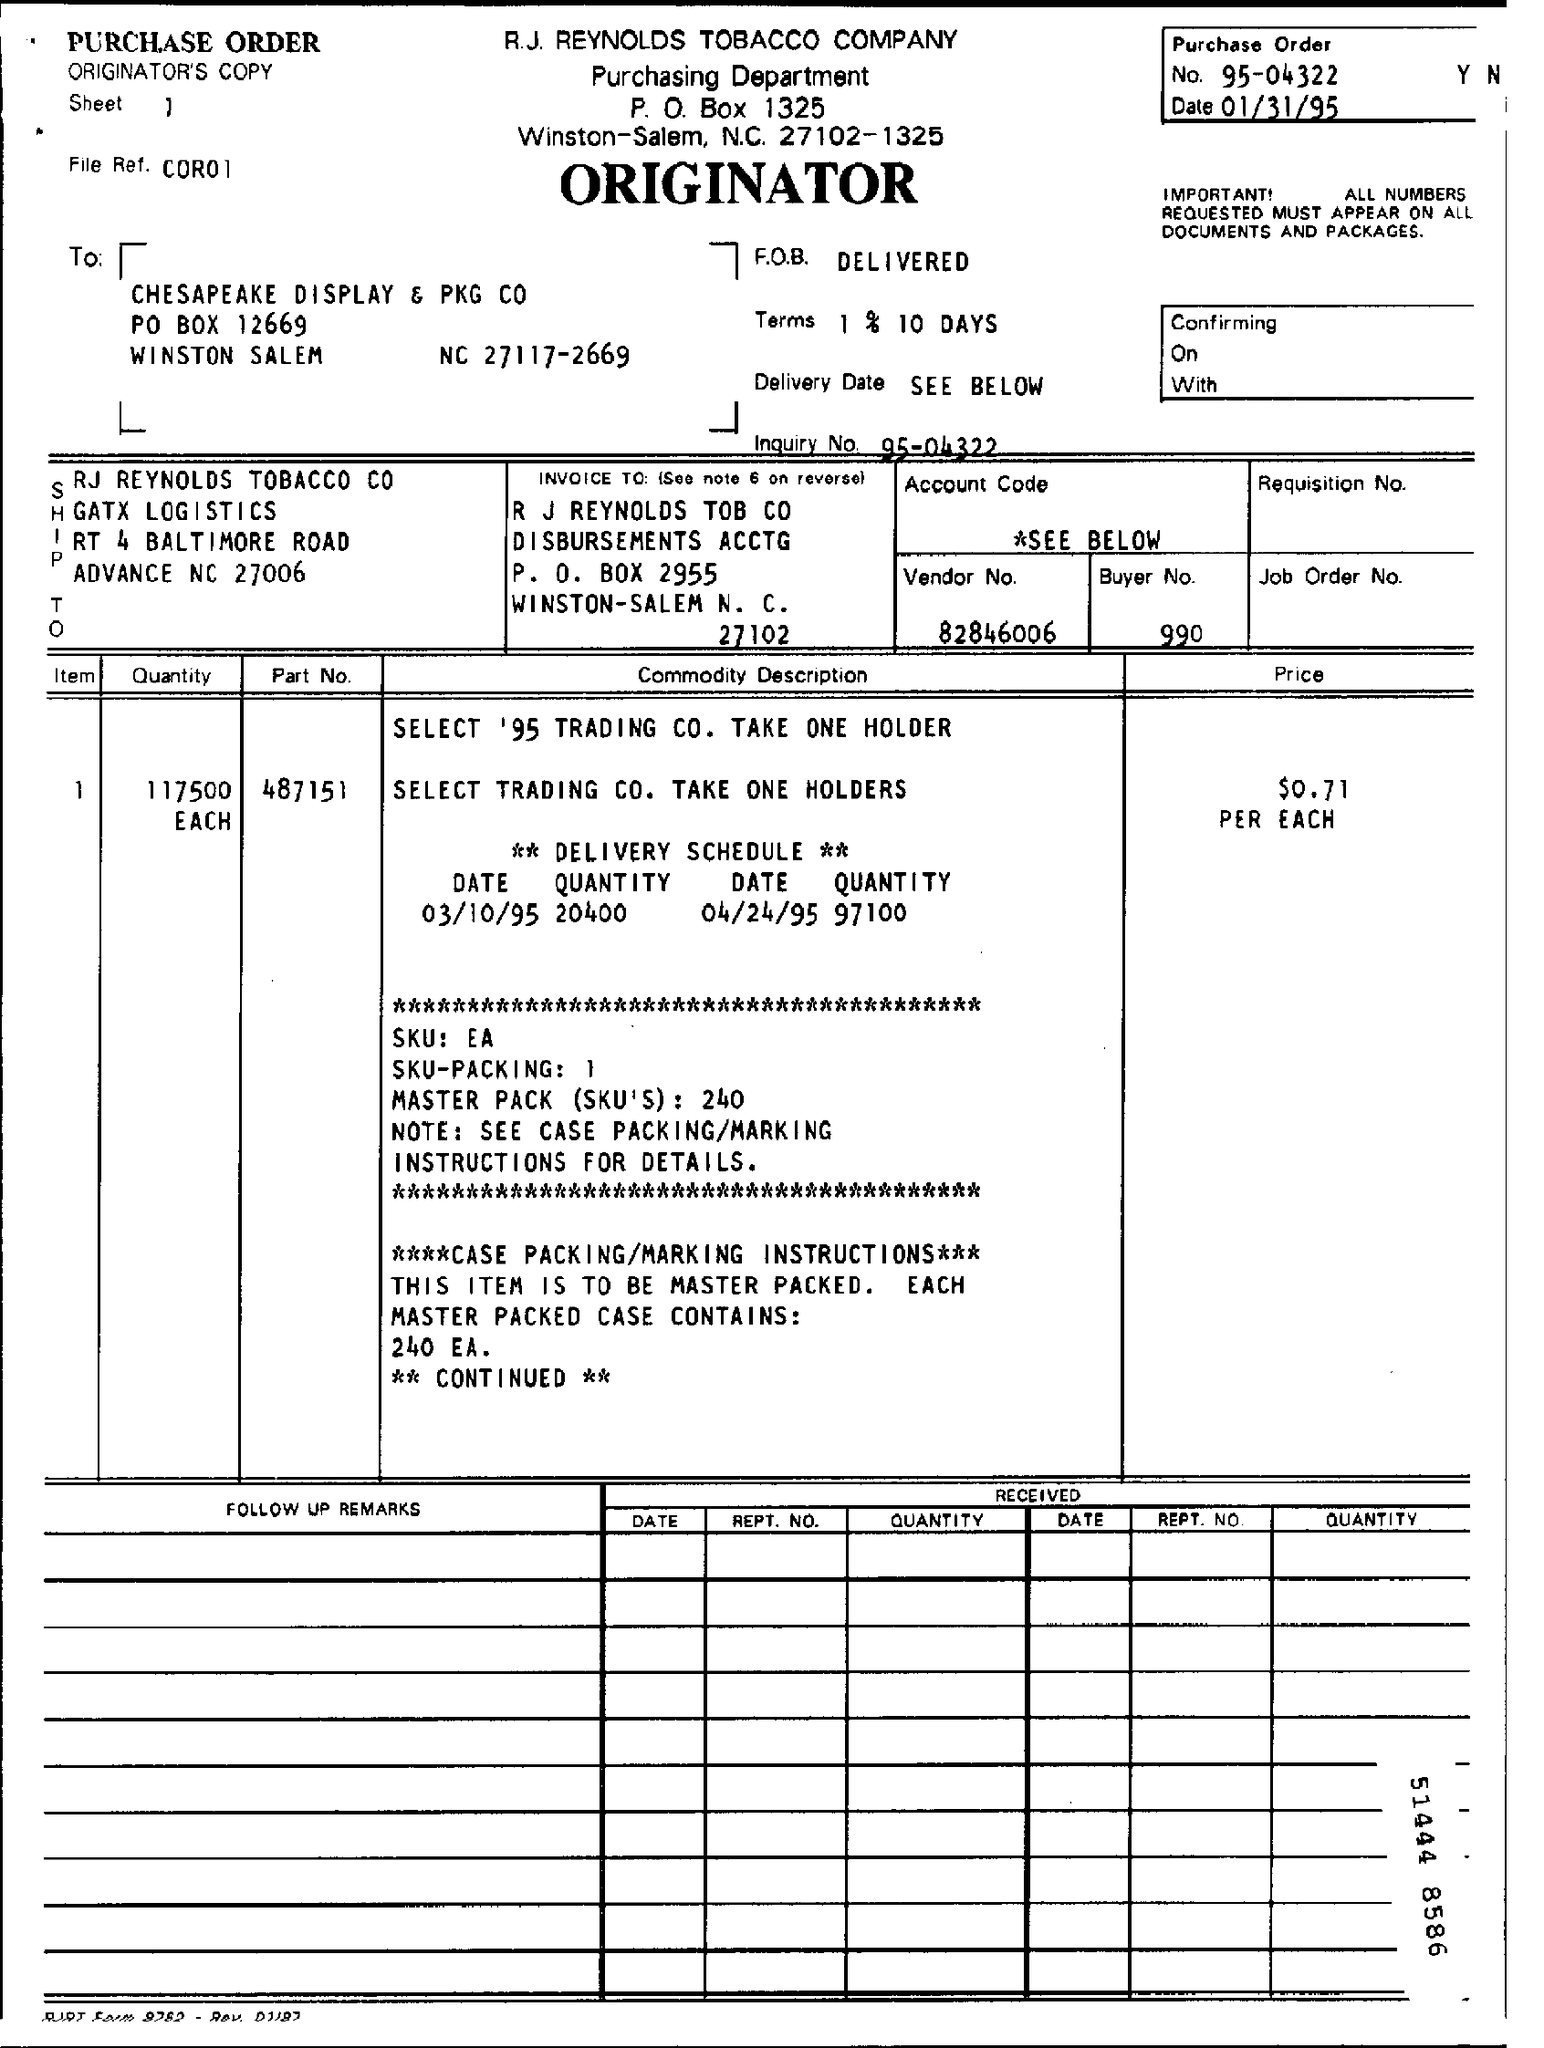Draw attention to some important aspects in this diagram. The price is $0.71. The vendor number is 82846006... The part number is 487151... The purchase order number is 95-04322... The inquiry number is 95-04322... 